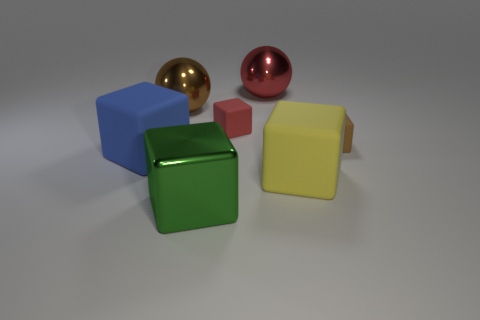Subtract all brown cubes. How many cubes are left? 4 Subtract all yellow matte blocks. How many blocks are left? 4 Subtract all cyan blocks. Subtract all green balls. How many blocks are left? 5 Add 2 tiny purple metallic balls. How many objects exist? 9 Subtract all cubes. How many objects are left? 2 Add 2 large blue rubber objects. How many large blue rubber objects are left? 3 Add 1 big rubber cubes. How many big rubber cubes exist? 3 Subtract 0 red cylinders. How many objects are left? 7 Subtract all big rubber blocks. Subtract all brown cubes. How many objects are left? 4 